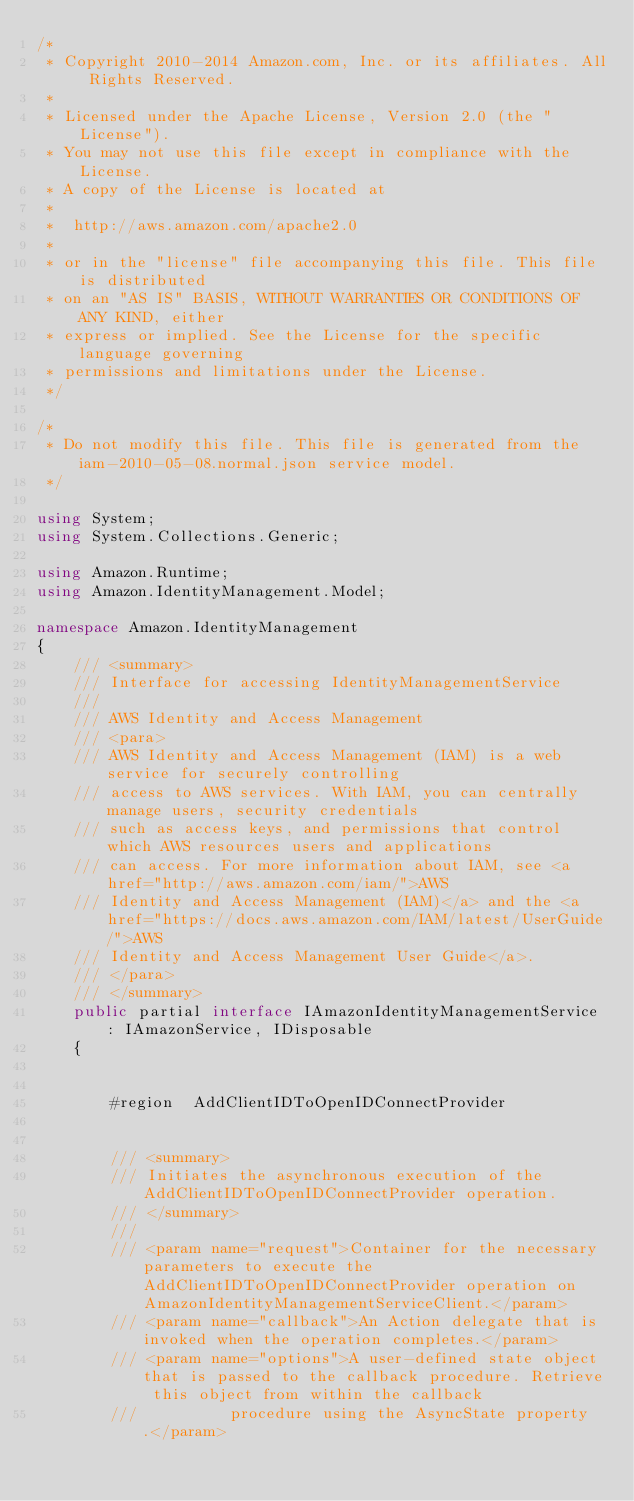Convert code to text. <code><loc_0><loc_0><loc_500><loc_500><_C#_>/*
 * Copyright 2010-2014 Amazon.com, Inc. or its affiliates. All Rights Reserved.
 * 
 * Licensed under the Apache License, Version 2.0 (the "License").
 * You may not use this file except in compliance with the License.
 * A copy of the License is located at
 * 
 *  http://aws.amazon.com/apache2.0
 * 
 * or in the "license" file accompanying this file. This file is distributed
 * on an "AS IS" BASIS, WITHOUT WARRANTIES OR CONDITIONS OF ANY KIND, either
 * express or implied. See the License for the specific language governing
 * permissions and limitations under the License.
 */

/*
 * Do not modify this file. This file is generated from the iam-2010-05-08.normal.json service model.
 */

using System;
using System.Collections.Generic;

using Amazon.Runtime;
using Amazon.IdentityManagement.Model;

namespace Amazon.IdentityManagement
{
    /// <summary>
    /// Interface for accessing IdentityManagementService
    ///
    /// AWS Identity and Access Management 
    /// <para>
    /// AWS Identity and Access Management (IAM) is a web service for securely controlling
    /// access to AWS services. With IAM, you can centrally manage users, security credentials
    /// such as access keys, and permissions that control which AWS resources users and applications
    /// can access. For more information about IAM, see <a href="http://aws.amazon.com/iam/">AWS
    /// Identity and Access Management (IAM)</a> and the <a href="https://docs.aws.amazon.com/IAM/latest/UserGuide/">AWS
    /// Identity and Access Management User Guide</a>.
    /// </para>
    /// </summary>
    public partial interface IAmazonIdentityManagementService : IAmazonService, IDisposable
    {

        
        #region  AddClientIDToOpenIDConnectProvider


        /// <summary>
        /// Initiates the asynchronous execution of the AddClientIDToOpenIDConnectProvider operation.
        /// </summary>
        /// 
        /// <param name="request">Container for the necessary parameters to execute the AddClientIDToOpenIDConnectProvider operation on AmazonIdentityManagementServiceClient.</param>
        /// <param name="callback">An Action delegate that is invoked when the operation completes.</param>
        /// <param name="options">A user-defined state object that is passed to the callback procedure. Retrieve this object from within the callback
        ///          procedure using the AsyncState property.</param></code> 